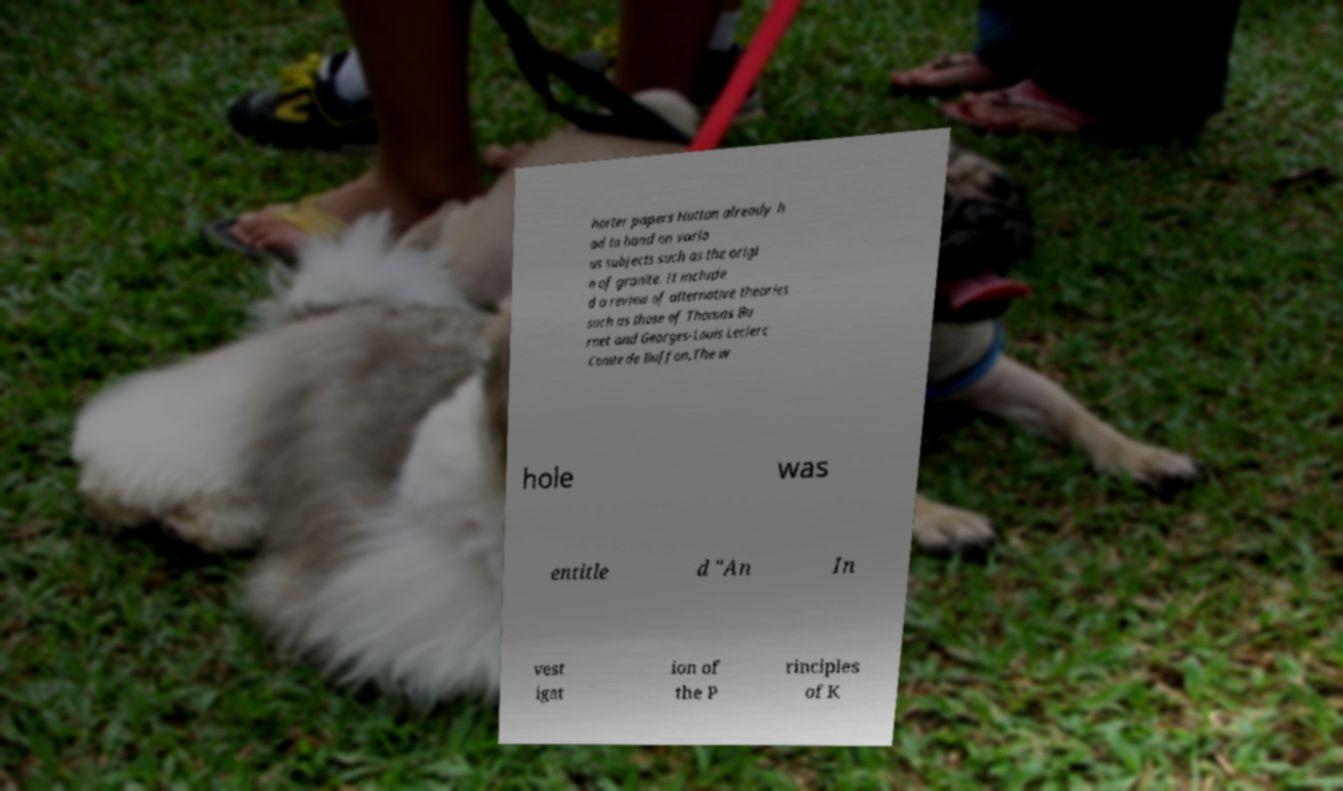There's text embedded in this image that I need extracted. Can you transcribe it verbatim? horter papers Hutton already h ad to hand on vario us subjects such as the origi n of granite. It include d a review of alternative theories such as those of Thomas Bu rnet and Georges-Louis Leclerc Comte de Buffon.The w hole was entitle d "An In vest igat ion of the P rinciples of K 